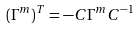Convert formula to latex. <formula><loc_0><loc_0><loc_500><loc_500>( \Gamma ^ { m } ) ^ { T } = - C \Gamma ^ { m } C ^ { - 1 }</formula> 